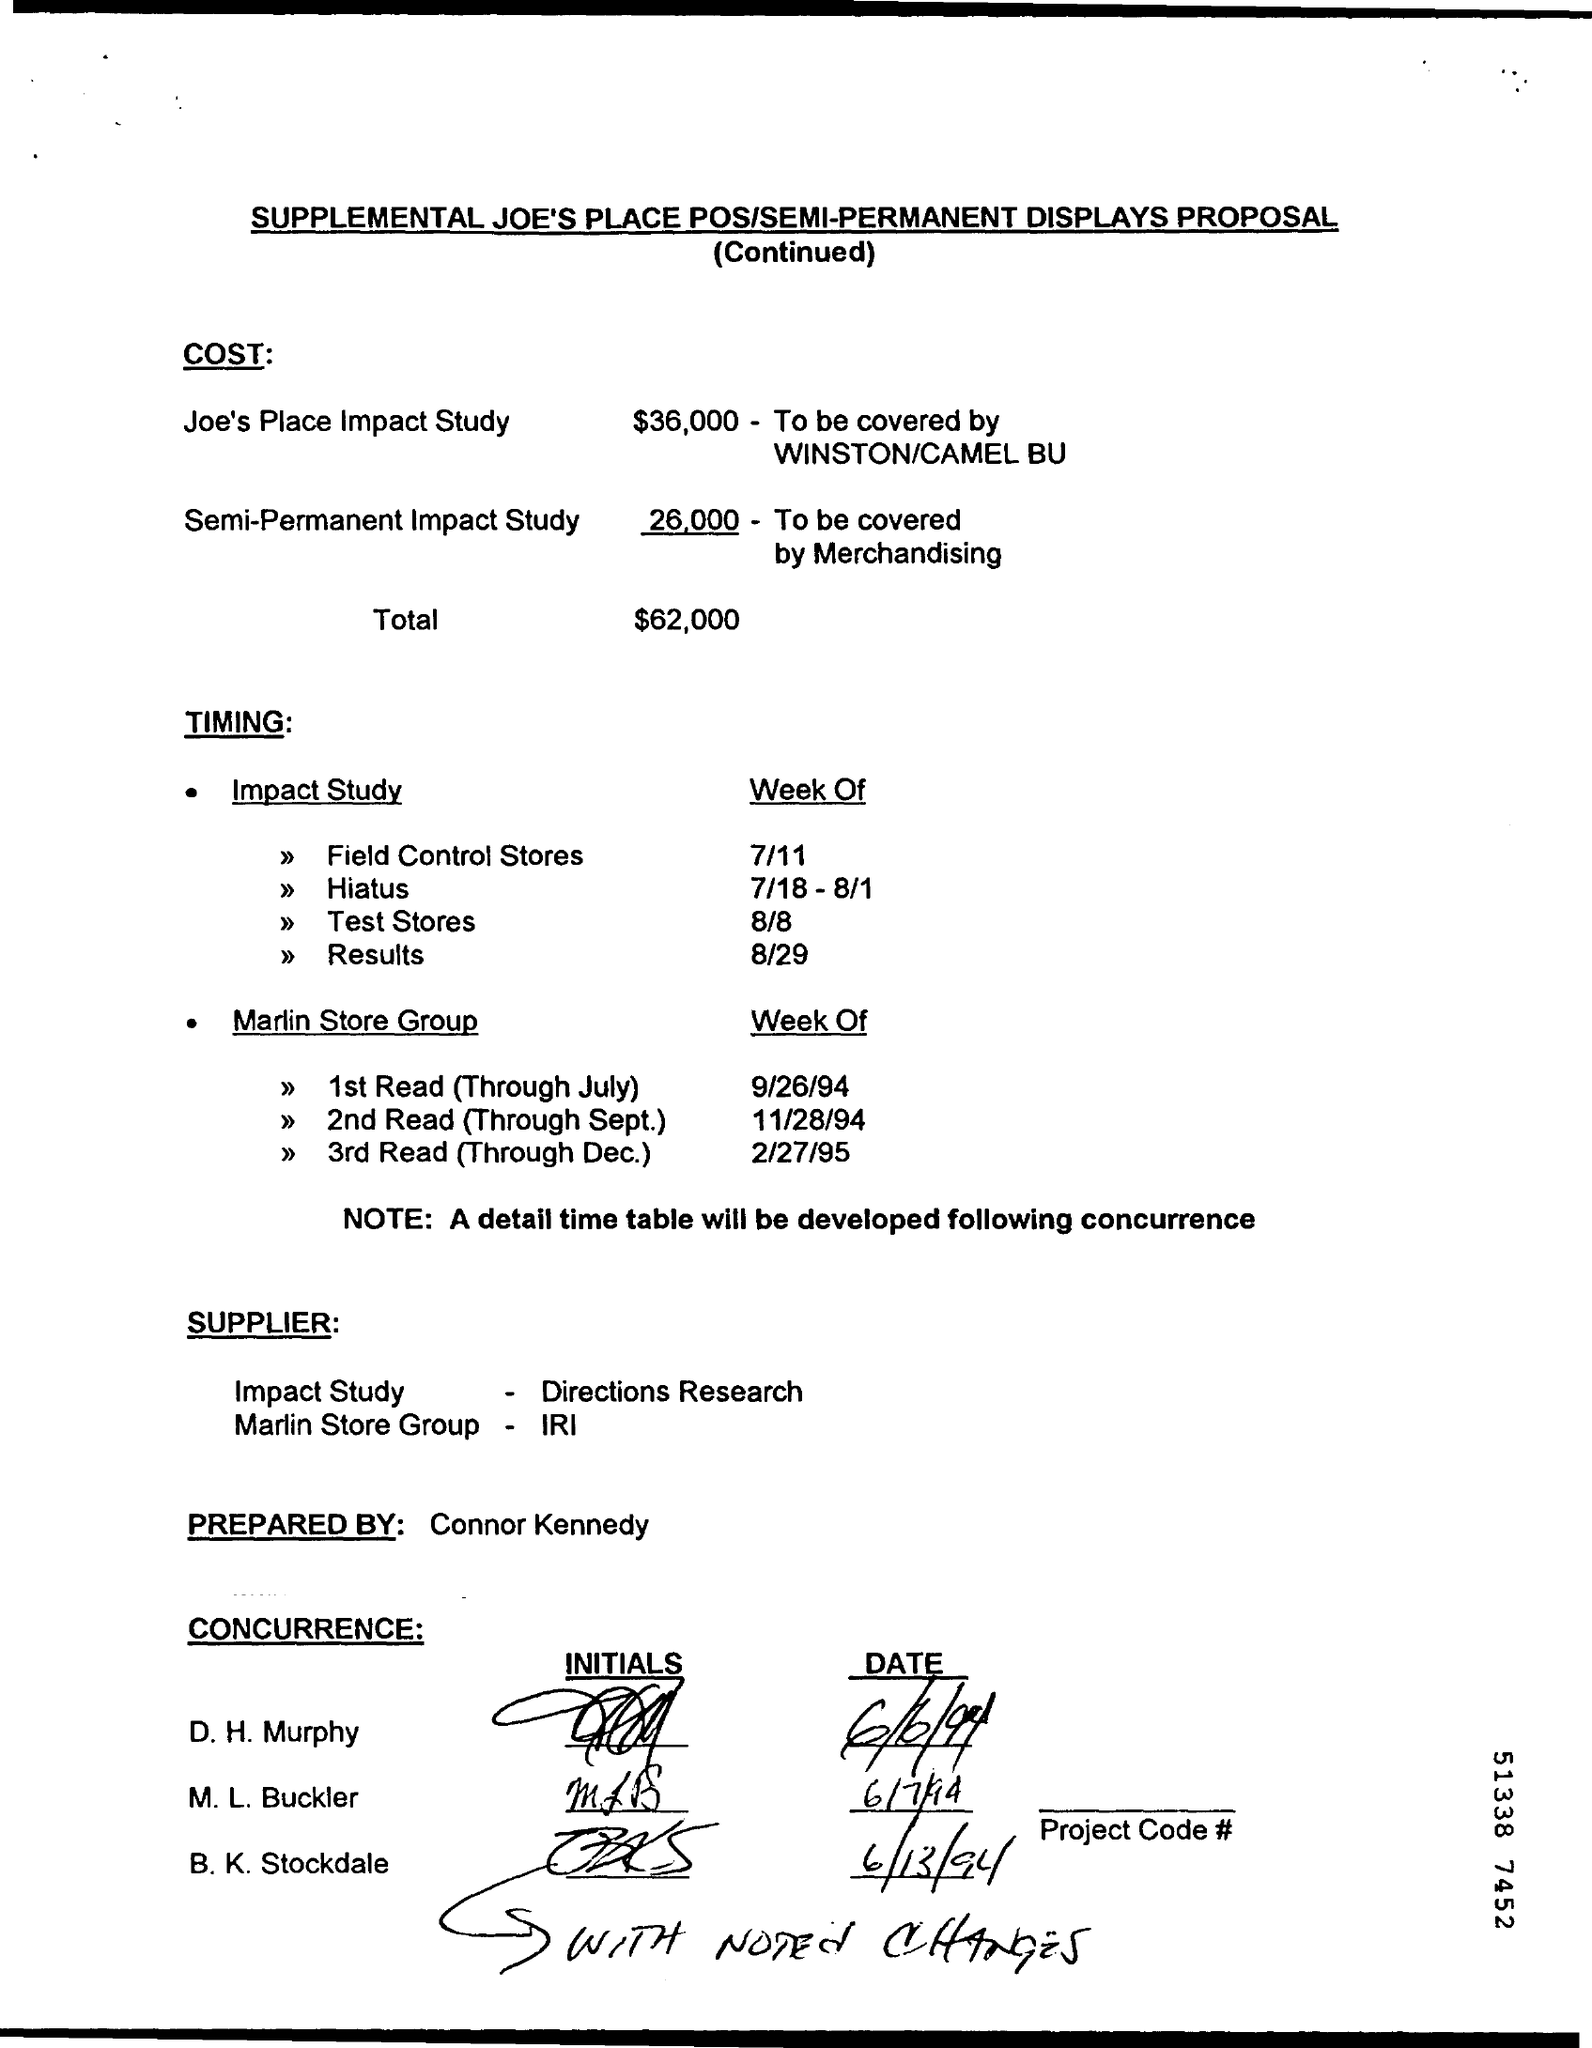Identify some key points in this picture. The cost of the Joe's Place Impact Study is $36,000. The proposal has been prepared by Connor Kennedy. The semi-permanent impact study will be covered by merchandising. 